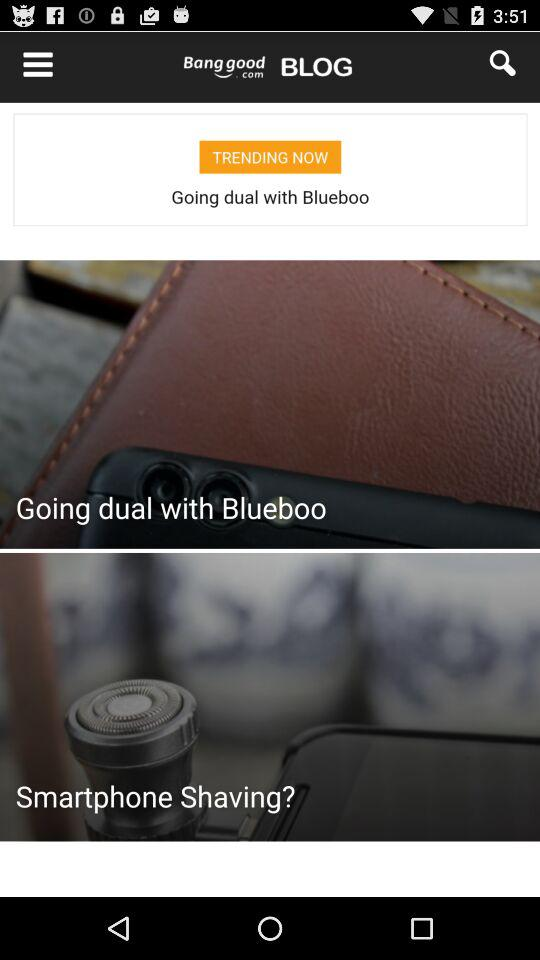How many likes are there? There are 23 likes. 